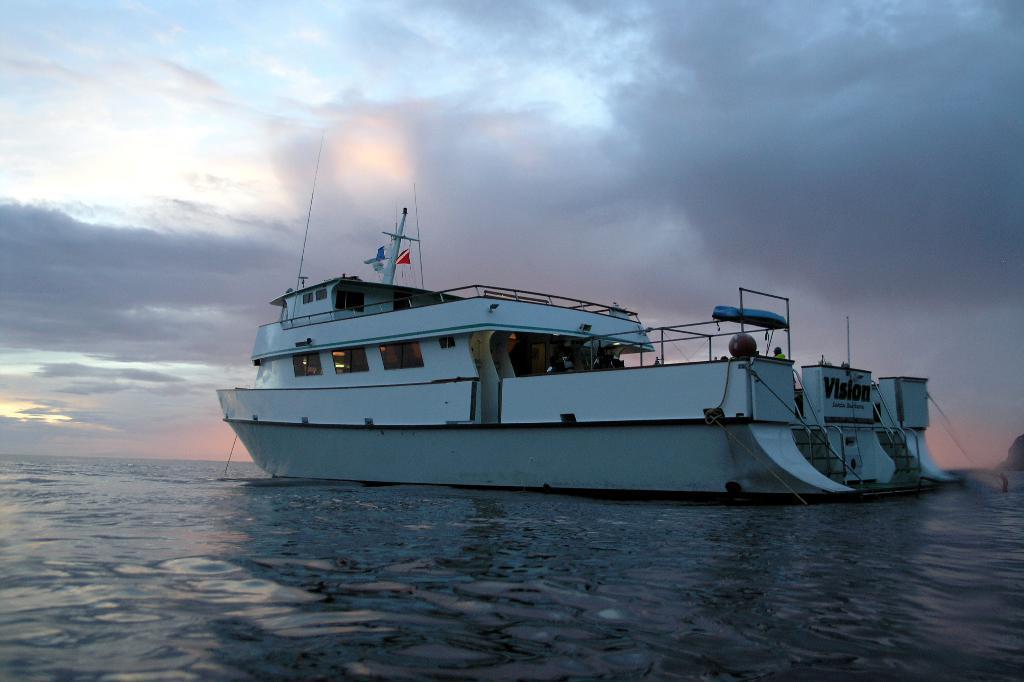Describe this image in one or two sentences. At the bottom of the picture, we see water and this water might be in the sea. In the middle of the picture, we see a boat in white color is sailing on the water. In the background, we see the sky. 